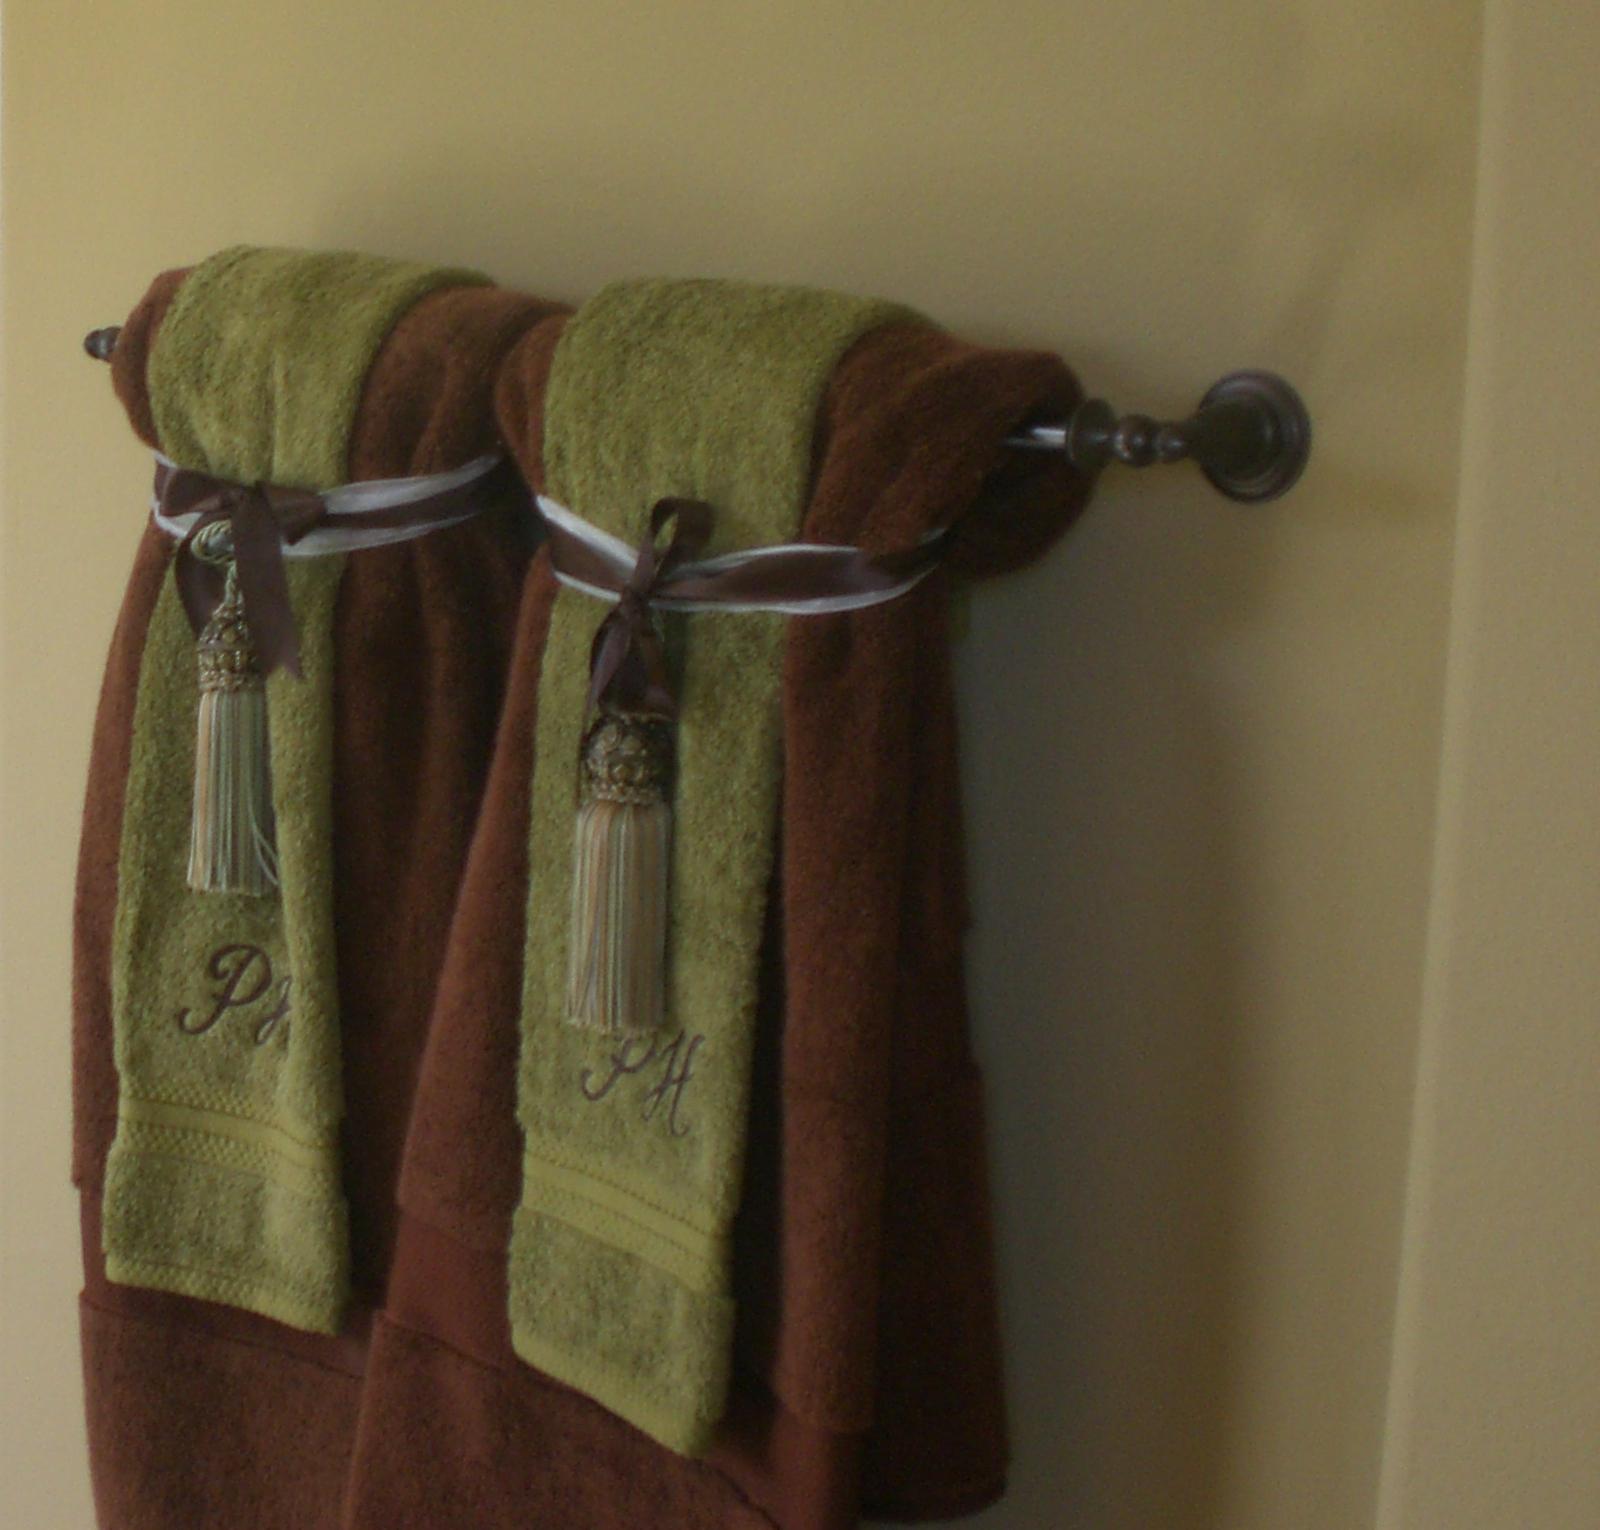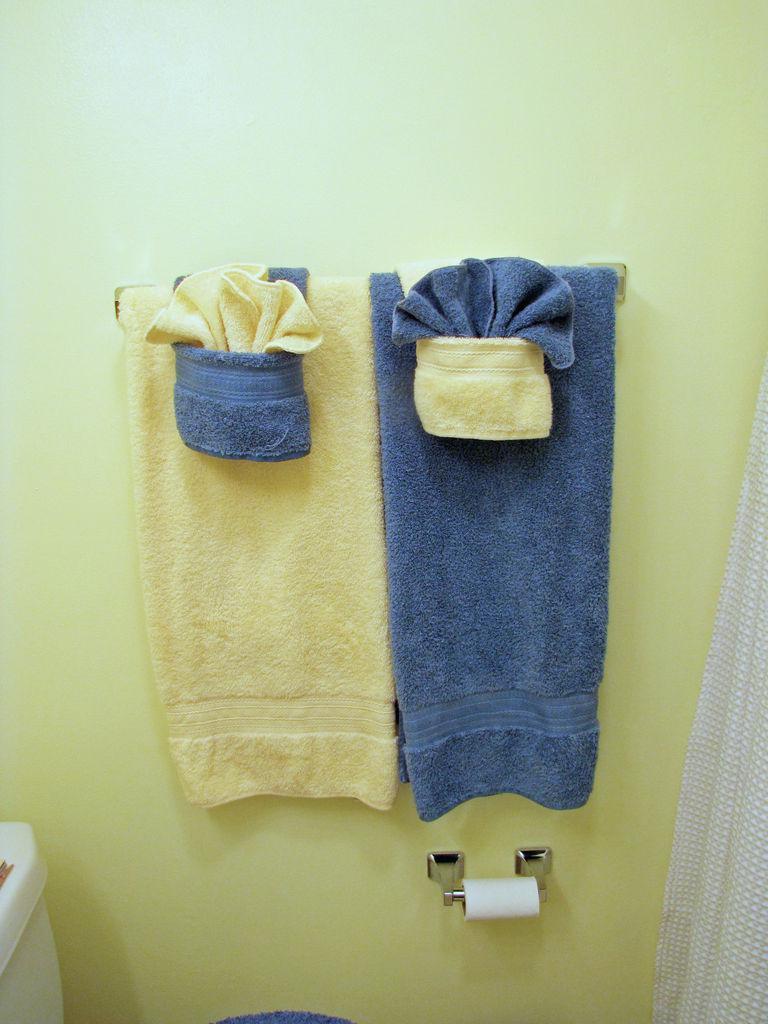The first image is the image on the left, the second image is the image on the right. Given the left and right images, does the statement "In the left image, we see one white towel, on a rack." hold true? Answer yes or no. No. 